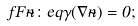Convert formula to latex. <formula><loc_0><loc_0><loc_500><loc_500>\ f F \tilde { n } \colon e q \gamma ( \nabla \tilde { n } ) = 0 ;</formula> 